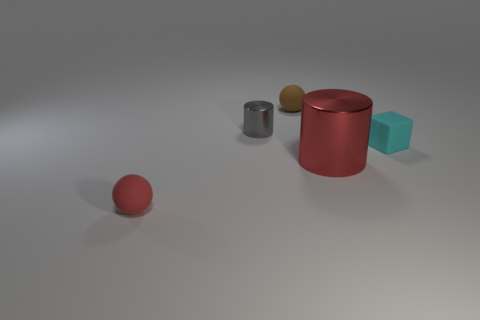Add 4 large blue rubber cubes. How many objects exist? 9 Subtract all spheres. How many objects are left? 3 Subtract 0 green cylinders. How many objects are left? 5 Subtract all big objects. Subtract all big red metal cylinders. How many objects are left? 3 Add 2 brown things. How many brown things are left? 3 Add 4 tiny purple cylinders. How many tiny purple cylinders exist? 4 